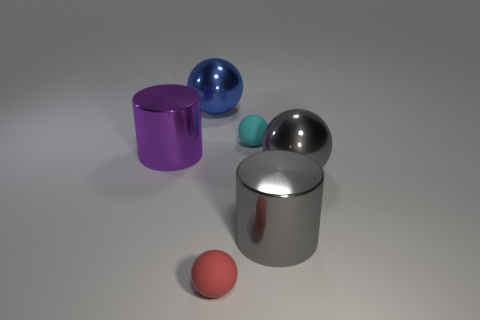Add 1 purple cylinders. How many objects exist? 7 Subtract all cylinders. How many objects are left? 4 Subtract all tiny cyan balls. Subtract all gray things. How many objects are left? 3 Add 3 metal spheres. How many metal spheres are left? 5 Add 1 large cylinders. How many large cylinders exist? 3 Subtract 0 brown balls. How many objects are left? 6 